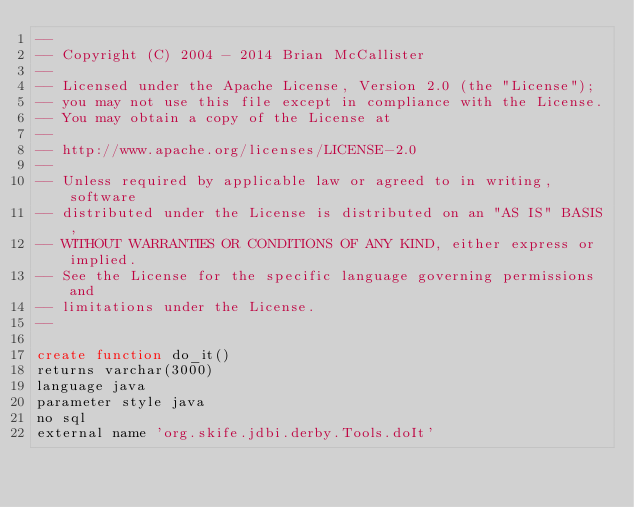<code> <loc_0><loc_0><loc_500><loc_500><_SQL_>--
-- Copyright (C) 2004 - 2014 Brian McCallister
--
-- Licensed under the Apache License, Version 2.0 (the "License");
-- you may not use this file except in compliance with the License.
-- You may obtain a copy of the License at
--
-- http://www.apache.org/licenses/LICENSE-2.0
--
-- Unless required by applicable law or agreed to in writing, software
-- distributed under the License is distributed on an "AS IS" BASIS,
-- WITHOUT WARRANTIES OR CONDITIONS OF ANY KIND, either express or implied.
-- See the License for the specific language governing permissions and
-- limitations under the License.
--

create function do_it()
returns varchar(3000)
language java
parameter style java
no sql
external name 'org.skife.jdbi.derby.Tools.doIt'</code> 